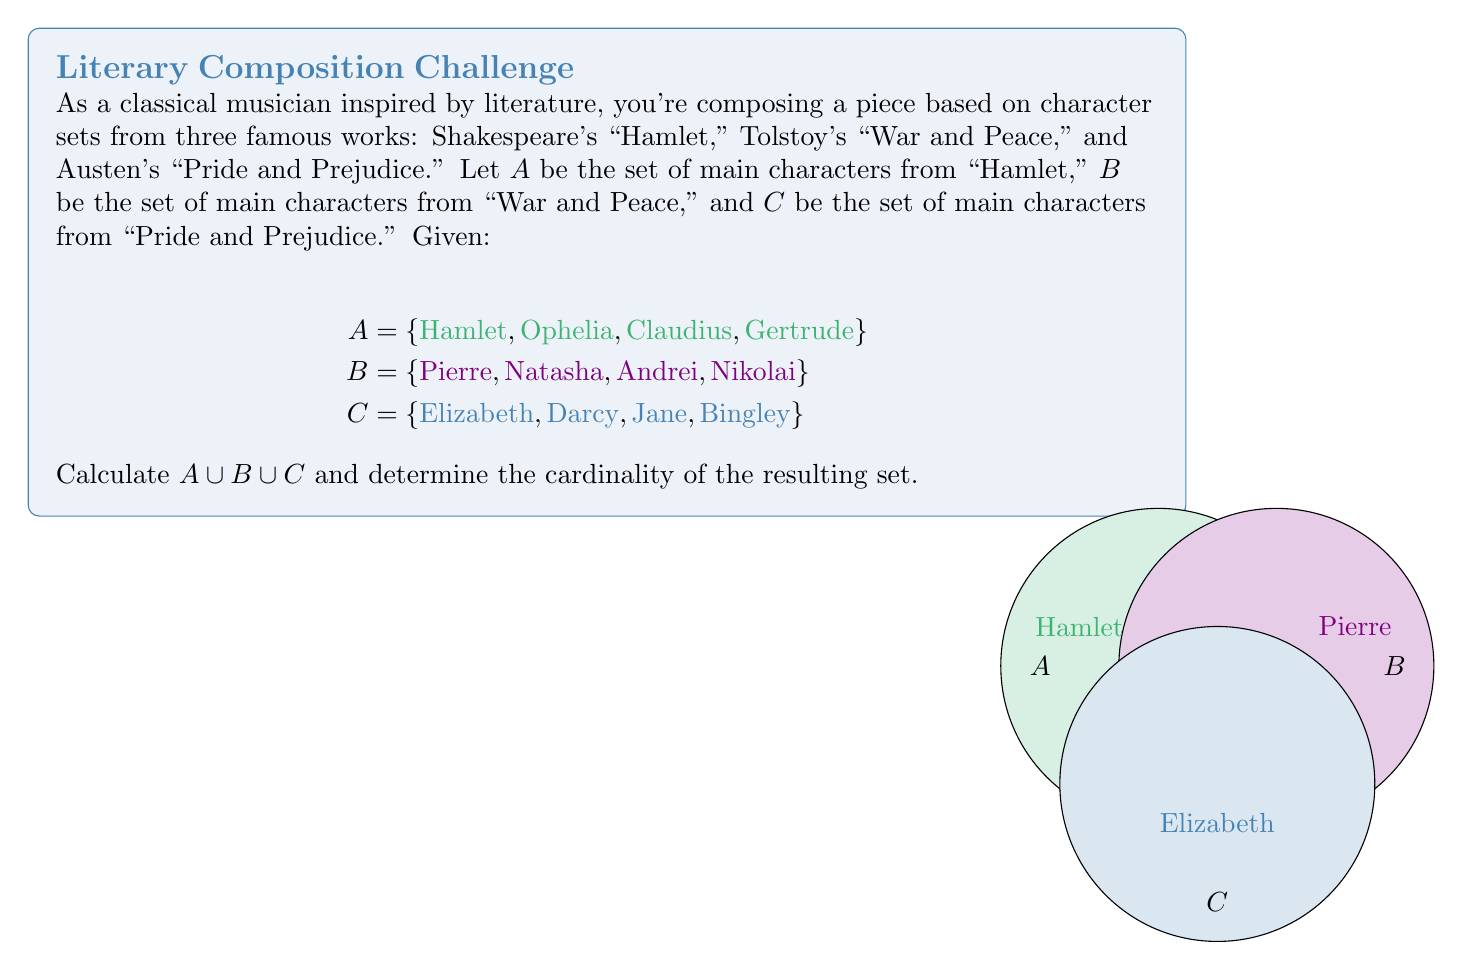Can you answer this question? To solve this problem, we need to follow these steps:

1) First, let's understand what $A \cup B \cup C$ means:
   This is the union of all three sets, which includes all elements that are in A, B, or C (or any combination of them).

2) In set theory, the union operation combines all unique elements from the given sets. Duplicates are not repeated in the result.

3) Let's list out all the elements from A, B, and C:
   A = {Hamlet, Ophelia, Claudius, Gertrude}
   B = {Pierre, Natasha, Andrei, Nikolai}
   C = {Elizabeth, Darcy, Jane, Bingley}

4) Now, we combine all these elements into a single set:
   $A \cup B \cup C$ = {Hamlet, Ophelia, Claudius, Gertrude, Pierre, Natasha, Andrei, Nikolai, Elizabeth, Darcy, Jane, Bingley}

5) To determine the cardinality (number of elements) of this set, we simply count the unique elements:
   $|A \cup B \cup C| = 12$

Note that there are no overlapping characters between these three literary works, so the union contains all elements from each set without any duplicates.
Answer: $|A \cup B \cup C| = 12$ 